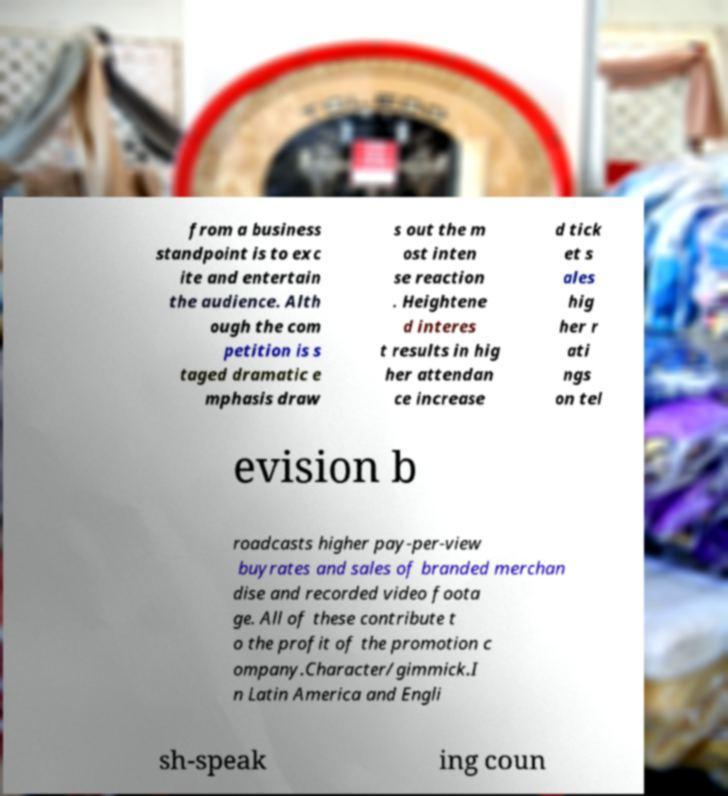Can you read and provide the text displayed in the image?This photo seems to have some interesting text. Can you extract and type it out for me? from a business standpoint is to exc ite and entertain the audience. Alth ough the com petition is s taged dramatic e mphasis draw s out the m ost inten se reaction . Heightene d interes t results in hig her attendan ce increase d tick et s ales hig her r ati ngs on tel evision b roadcasts higher pay-per-view buyrates and sales of branded merchan dise and recorded video foota ge. All of these contribute t o the profit of the promotion c ompany.Character/gimmick.I n Latin America and Engli sh-speak ing coun 